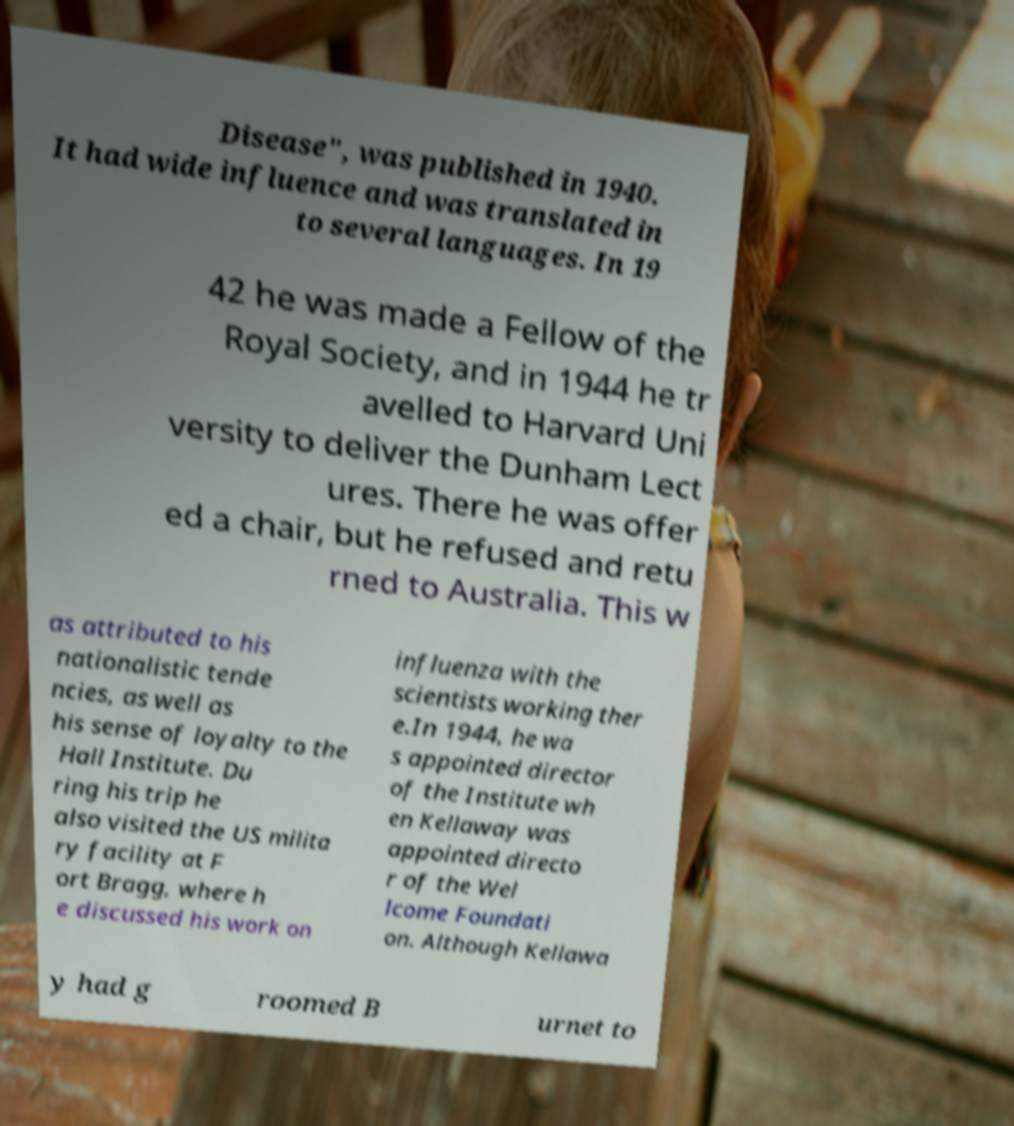There's text embedded in this image that I need extracted. Can you transcribe it verbatim? Disease", was published in 1940. It had wide influence and was translated in to several languages. In 19 42 he was made a Fellow of the Royal Society, and in 1944 he tr avelled to Harvard Uni versity to deliver the Dunham Lect ures. There he was offer ed a chair, but he refused and retu rned to Australia. This w as attributed to his nationalistic tende ncies, as well as his sense of loyalty to the Hall Institute. Du ring his trip he also visited the US milita ry facility at F ort Bragg, where h e discussed his work on influenza with the scientists working ther e.In 1944, he wa s appointed director of the Institute wh en Kellaway was appointed directo r of the Wel lcome Foundati on. Although Kellawa y had g roomed B urnet to 